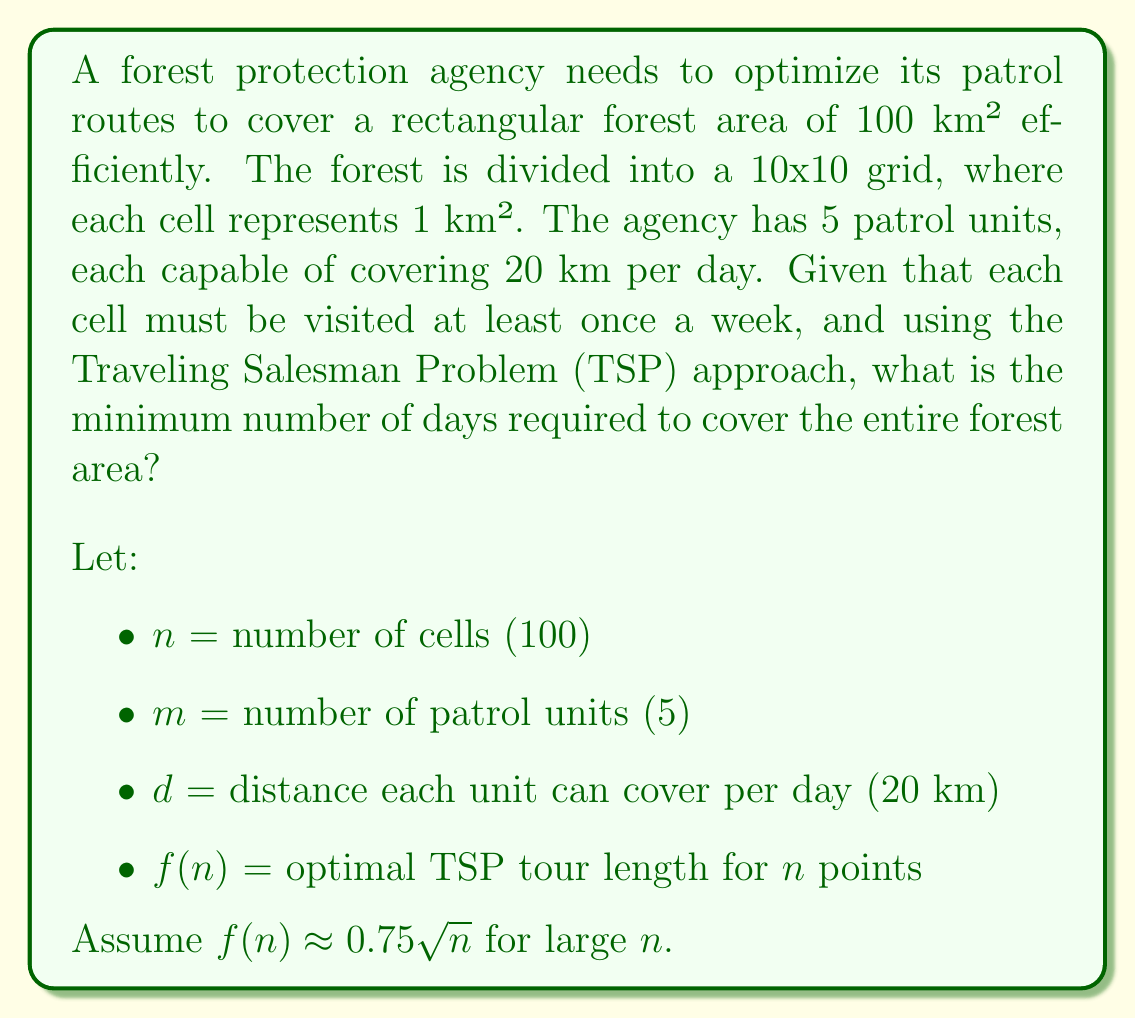What is the answer to this math problem? To solve this problem, we need to follow these steps:

1. Calculate the total distance that needs to be covered:
   The TSP tour length for 100 points is approximately:
   $$f(100) \approx 0.75\sqrt{100} = 0.75 \times 10 = 7.5 \text{ km}$$

2. Calculate the total distance that can be covered by all units in one day:
   $$\text{Total daily coverage} = m \times d = 5 \times 20 = 100 \text{ km}$$

3. Calculate the number of days required to cover the entire forest:
   $$\text{Days required} = \left\lceil\frac{f(n)}{m \times d} \times 7\right\rceil$$

   Here, we multiply by 7 because each cell must be visited at least once a week.

4. Substitute the values:
   $$\text{Days required} = \left\lceil\frac{7.5}{100} \times 7\right\rceil = \left\lceil0.525\right\rceil = 1 \text{ day}$$

The ceiling function $\lceil \rceil$ is used to round up to the nearest whole day, as we can't have a fractional number of days.
Answer: 1 day 